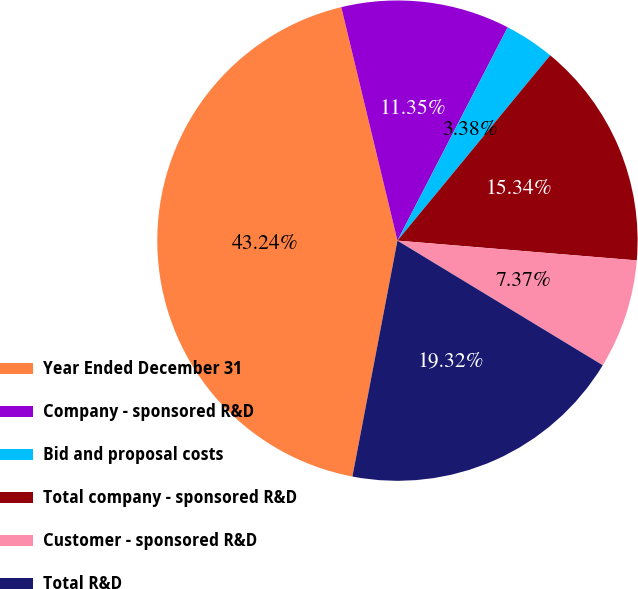Convert chart. <chart><loc_0><loc_0><loc_500><loc_500><pie_chart><fcel>Year Ended December 31<fcel>Company - sponsored R&D<fcel>Bid and proposal costs<fcel>Total company - sponsored R&D<fcel>Customer - sponsored R&D<fcel>Total R&D<nl><fcel>43.24%<fcel>11.35%<fcel>3.38%<fcel>15.34%<fcel>7.37%<fcel>19.32%<nl></chart> 